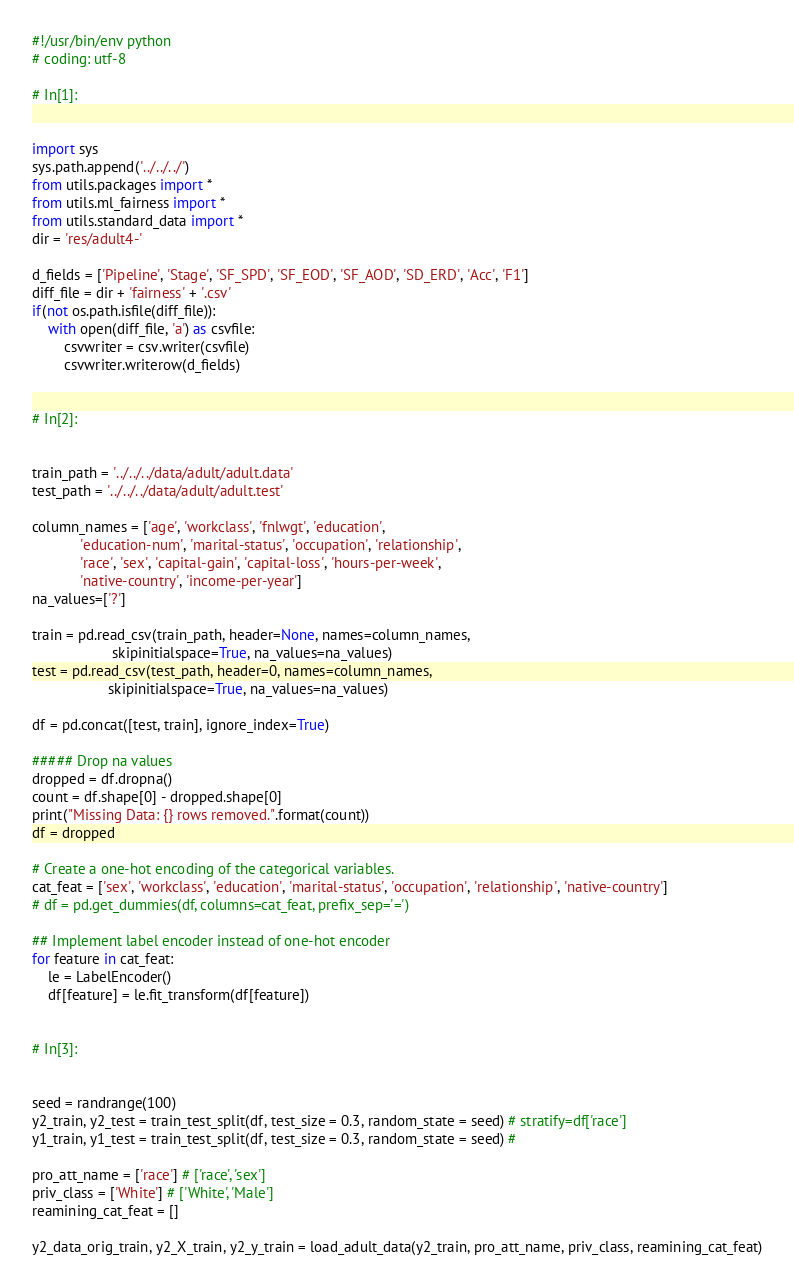Convert code to text. <code><loc_0><loc_0><loc_500><loc_500><_Python_>#!/usr/bin/env python
# coding: utf-8

# In[1]:


import sys
sys.path.append('../../../')
from utils.packages import *
from utils.ml_fairness import *
from utils.standard_data import *
dir = 'res/adult4-'

d_fields = ['Pipeline', 'Stage', 'SF_SPD', 'SF_EOD', 'SF_AOD', 'SD_ERD', 'Acc', 'F1']
diff_file = dir + 'fairness' + '.csv'
if(not os.path.isfile(diff_file)):
    with open(diff_file, 'a') as csvfile:
        csvwriter = csv.writer(csvfile)
        csvwriter.writerow(d_fields)


# In[2]:


train_path = '../../../data/adult/adult.data'
test_path = '../../../data/adult/adult.test'

column_names = ['age', 'workclass', 'fnlwgt', 'education',
            'education-num', 'marital-status', 'occupation', 'relationship',
            'race', 'sex', 'capital-gain', 'capital-loss', 'hours-per-week',
            'native-country', 'income-per-year']
na_values=['?']

train = pd.read_csv(train_path, header=None, names=column_names, 
                    skipinitialspace=True, na_values=na_values)
test = pd.read_csv(test_path, header=0, names=column_names,
                   skipinitialspace=True, na_values=na_values)

df = pd.concat([test, train], ignore_index=True)

##### Drop na values
dropped = df.dropna()
count = df.shape[0] - dropped.shape[0]
print("Missing Data: {} rows removed.".format(count))
df = dropped

# Create a one-hot encoding of the categorical variables.
cat_feat = ['sex', 'workclass', 'education', 'marital-status', 'occupation', 'relationship', 'native-country']
# df = pd.get_dummies(df, columns=cat_feat, prefix_sep='=')

## Implement label encoder instead of one-hot encoder
for feature in cat_feat:
    le = LabelEncoder()
    df[feature] = le.fit_transform(df[feature])


# In[3]:


seed = randrange(100)
y2_train, y2_test = train_test_split(df, test_size = 0.3, random_state = seed) # stratify=df['race']
y1_train, y1_test = train_test_split(df, test_size = 0.3, random_state = seed) # 

pro_att_name = ['race'] # ['race', 'sex']
priv_class = ['White'] # ['White', 'Male']
reamining_cat_feat = []

y2_data_orig_train, y2_X_train, y2_y_train = load_adult_data(y2_train, pro_att_name, priv_class, reamining_cat_feat)</code> 